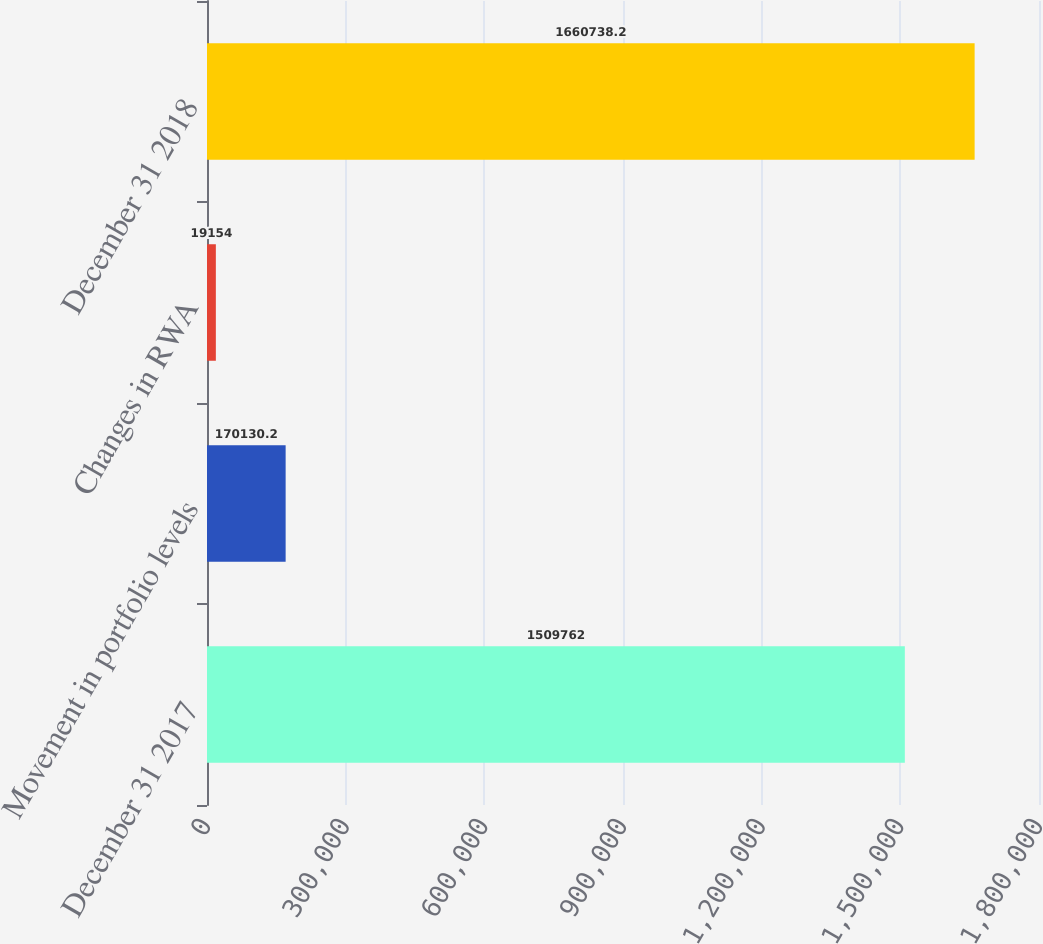Convert chart to OTSL. <chart><loc_0><loc_0><loc_500><loc_500><bar_chart><fcel>December 31 2017<fcel>Movement in portfolio levels<fcel>Changes in RWA<fcel>December 31 2018<nl><fcel>1.50976e+06<fcel>170130<fcel>19154<fcel>1.66074e+06<nl></chart> 